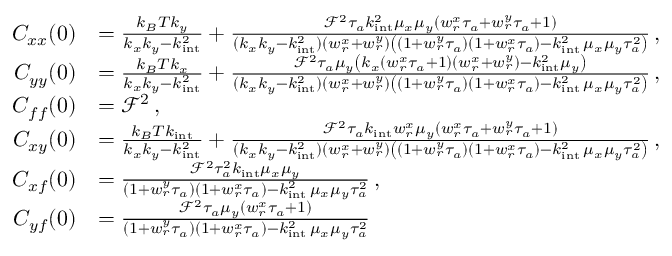Convert formula to latex. <formula><loc_0><loc_0><loc_500><loc_500>\begin{array} { r l } { C _ { x x } ( 0 ) } & { = \frac { k _ { B } T k _ { y } } { k _ { x } k _ { y } - k _ { i n t } ^ { 2 } } + \frac { \mathcal { F } ^ { 2 } \tau _ { a } k _ { i n t } ^ { 2 } \mu _ { x } \mu _ { y } ( w _ { r } ^ { x } \tau _ { a } + w _ { r } ^ { y } \tau _ { a } + 1 ) } { ( k _ { x } k _ { y } - k _ { i n t } ^ { 2 } ) ( w _ { r } ^ { x } + w _ { r } ^ { y } ) \left ( ( 1 + w _ { r } ^ { y } \tau _ { a } ) ( 1 + w _ { r } ^ { x } \tau _ { a } ) - k _ { i n t } ^ { 2 } \, \mu _ { x } \mu _ { y } \tau _ { a } ^ { 2 } \right ) } \, , } \\ { C _ { y y } ( 0 ) } & { = \frac { k _ { B } T k _ { x } } { k _ { x } k _ { y } - k _ { i n t } ^ { 2 } } + \frac { \mathcal { F } ^ { 2 } \tau _ { a } \mu _ { y } \left ( k _ { x } ( w _ { r } ^ { x } \tau _ { a } + 1 ) ( w _ { r } ^ { x } + w _ { r } ^ { y } ) - k _ { i n t } ^ { 2 } \mu _ { y } \right ) } { ( k _ { x } k _ { y } - k _ { i n t } ^ { 2 } ) ( w _ { r } ^ { x } + w _ { r } ^ { y } ) \left ( ( 1 + w _ { r } ^ { y } \tau _ { a } ) ( 1 + w _ { r } ^ { x } \tau _ { a } ) - k _ { i n t } ^ { 2 } \, \mu _ { x } \mu _ { y } \tau _ { a } ^ { 2 } \right ) } \, , } \\ { C _ { f f } ( 0 ) } & { = \mathcal { F } ^ { 2 } \, , } \\ { C _ { x y } ( 0 ) } & { = \frac { k _ { B } T k _ { i n t } } { k _ { x } k _ { y } - k _ { i n t } ^ { 2 } } + \frac { \mathcal { F } ^ { 2 } \tau _ { a } k _ { i n t } w _ { r } ^ { x } \mu _ { y } ( w _ { r } ^ { x } \tau _ { a } + w _ { r } ^ { y } \tau _ { a } + 1 ) } { ( k _ { x } k _ { y } - k _ { i n t } ^ { 2 } ) ( w _ { r } ^ { x } + w _ { r } ^ { y } ) \left ( ( 1 + w _ { r } ^ { y } \tau _ { a } ) ( 1 + w _ { r } ^ { x } \tau _ { a } ) - k _ { i n t } ^ { 2 } \, \mu _ { x } \mu _ { y } \tau _ { a } ^ { 2 } \right ) } \, , } \\ { C _ { x f } ( 0 ) } & { = \frac { \mathcal { F } ^ { 2 } \tau _ { a } ^ { 2 } k _ { i n t } \mu _ { x } \mu _ { y } } { ( 1 + w _ { r } ^ { y } \tau _ { a } ) ( 1 + w _ { r } ^ { x } \tau _ { a } ) - k _ { i n t } ^ { 2 } \, \mu _ { x } \mu _ { y } \tau _ { a } ^ { 2 } } \, , } \\ { C _ { y f } ( 0 ) } & { = \frac { \mathcal { F } ^ { 2 } \tau _ { a } \mu _ { y } ( w _ { r } ^ { x } \tau _ { a } + 1 ) } { ( 1 + w _ { r } ^ { y } \tau _ { a } ) ( 1 + w _ { r } ^ { x } \tau _ { a } ) - k _ { i n t } ^ { 2 } \, \mu _ { x } \mu _ { y } \tau _ { a } ^ { 2 } } \, } \end{array}</formula> 